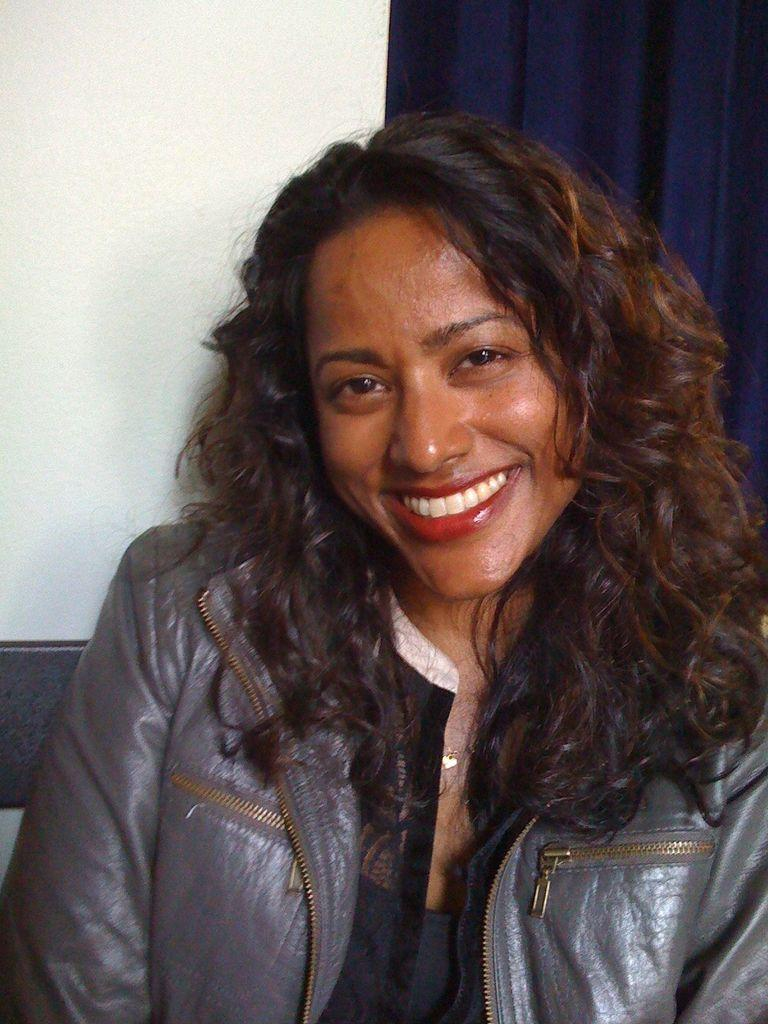Who is present in the image? There is a woman in the image. What is the woman wearing? The woman is wearing a jacket. What can be seen in the background of the image? There is a wall and a blue curtain in the background of the image. Where is the stove located in the image? There is no stove present in the image. What type of scale can be seen on the wall in the image? There is no scale present in the image. 